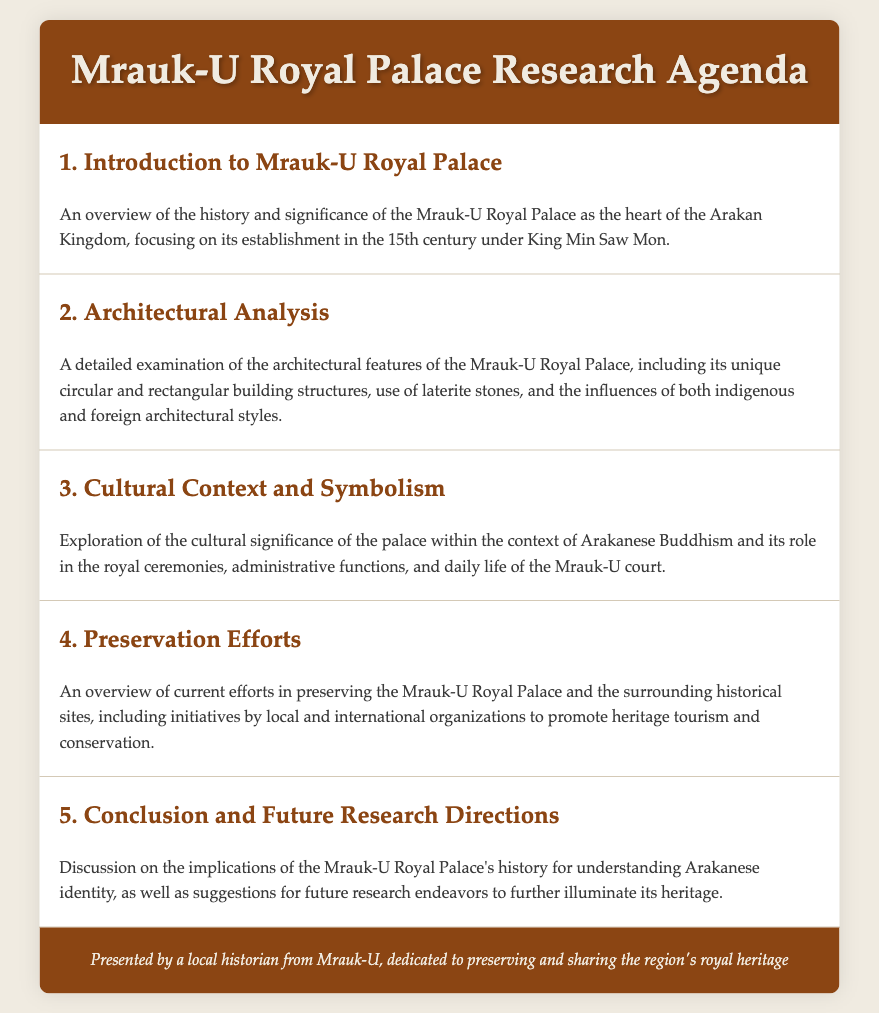What is the establishment century of the Mrauk-U Royal Palace? The document states that the Mrauk-U Royal Palace was established in the 15th century under King Min Saw Mon.
Answer: 15th century What architectural materials are mentioned for Mrauk-U Royal Palace? The agenda specifies that the palace features the use of laterite stones in its construction.
Answer: Laterite stones Which king established the Mrauk-U Royal Palace? The introduction mentions King Min Saw Mon as the founder of the Mrauk-U Royal Palace.
Answer: King Min Saw Mon What is the focus of the research agenda? The agenda outlines several key areas of research, including historical significance, architectural analysis, cultural context, preservation efforts, and future research directions.
Answer: Historical significance What aspect does the cultural context and symbolism item explore? This section explores the palace's importance within the context of Arakanese Buddhism and its impact on royal ceremonies and daily life.
Answer: Arakanese Buddhism How many items are listed in the research agenda? The document contains five main agenda items that cover different aspects of the Mrauk-U Royal Palace.
Answer: Five What is one goal of the preservation efforts discussed? The agenda mentions promoting heritage tourism and conservation as primary goals of the preservation initiatives.
Answer: Heritage tourism What is emphasized in the conclusion section of the agenda? The conclusion discusses the implications of the palace's history for understanding Arakanese identity and suggests future research directions.
Answer: Arakanese identity 